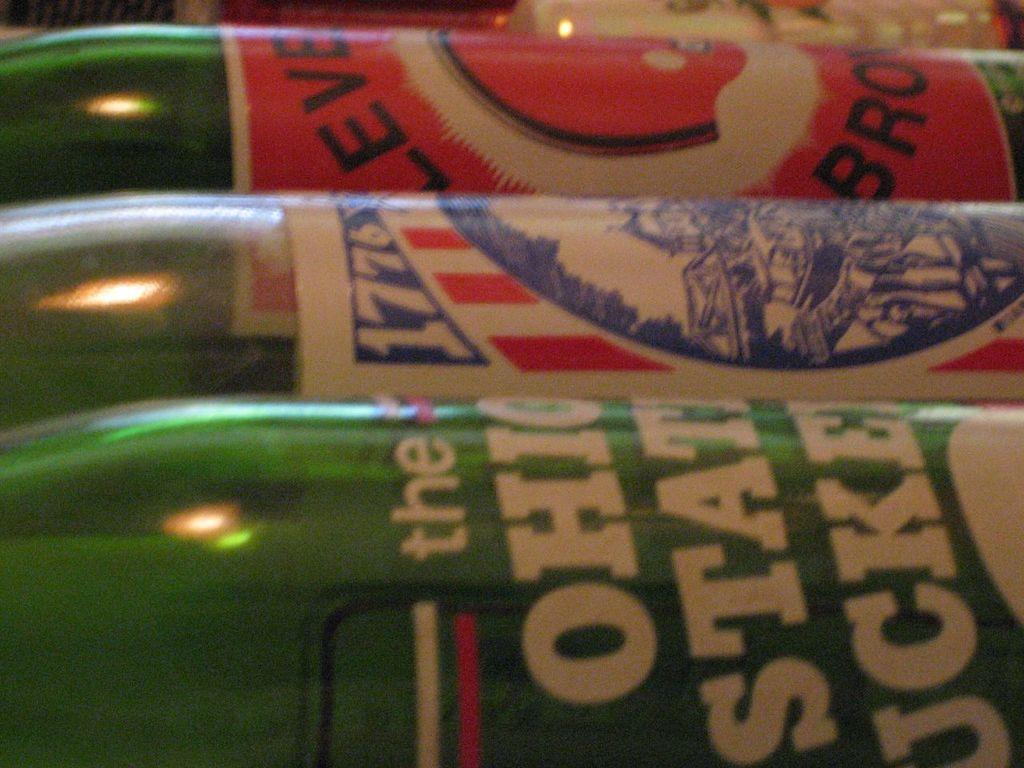What year is on the middle beer bottle?
Offer a terse response. 1776. What team is on the green bottle?
Your answer should be very brief. Ohio state. 